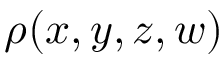<formula> <loc_0><loc_0><loc_500><loc_500>\rho ( x , y , z , w )</formula> 